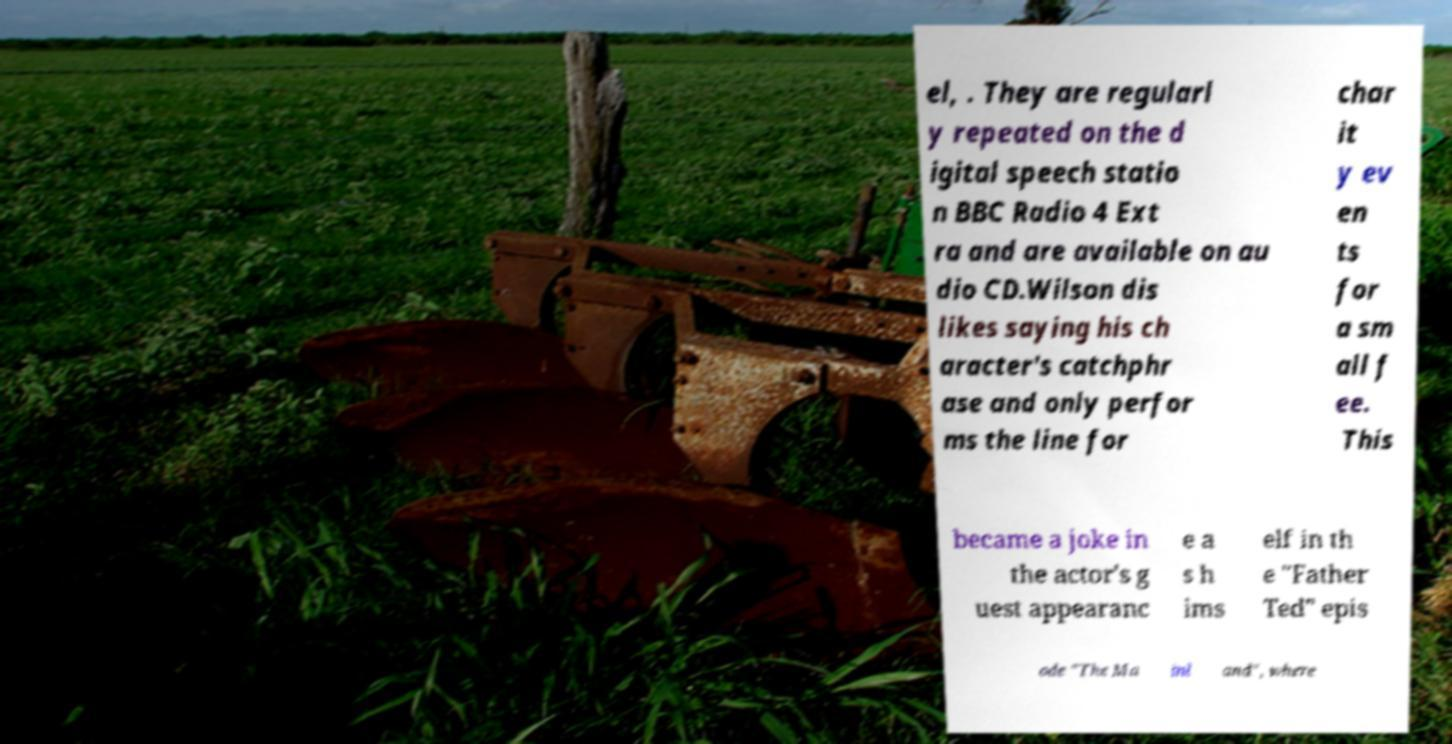Could you assist in decoding the text presented in this image and type it out clearly? el, . They are regularl y repeated on the d igital speech statio n BBC Radio 4 Ext ra and are available on au dio CD.Wilson dis likes saying his ch aracter's catchphr ase and only perfor ms the line for char it y ev en ts for a sm all f ee. This became a joke in the actor's g uest appearanc e a s h ims elf in th e "Father Ted" epis ode "The Ma inl and", where 